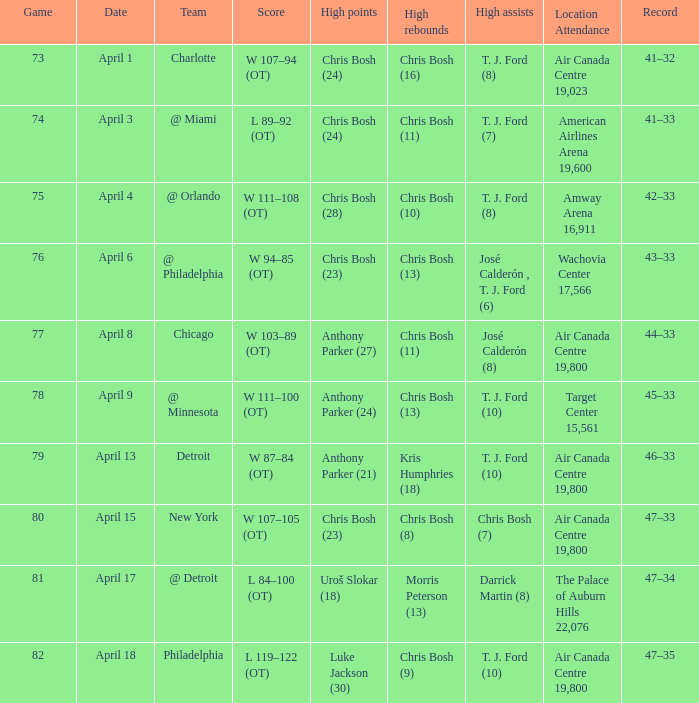What were the assists on April 8 in game less than 78? José Calderón (8). 